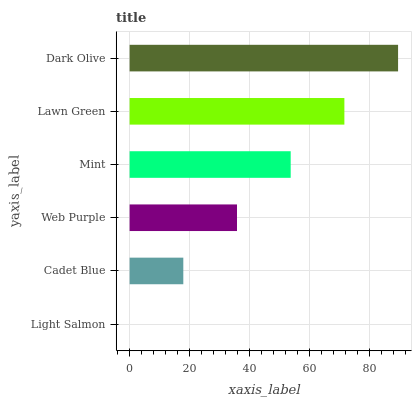Is Light Salmon the minimum?
Answer yes or no. Yes. Is Dark Olive the maximum?
Answer yes or no. Yes. Is Cadet Blue the minimum?
Answer yes or no. No. Is Cadet Blue the maximum?
Answer yes or no. No. Is Cadet Blue greater than Light Salmon?
Answer yes or no. Yes. Is Light Salmon less than Cadet Blue?
Answer yes or no. Yes. Is Light Salmon greater than Cadet Blue?
Answer yes or no. No. Is Cadet Blue less than Light Salmon?
Answer yes or no. No. Is Mint the high median?
Answer yes or no. Yes. Is Web Purple the low median?
Answer yes or no. Yes. Is Web Purple the high median?
Answer yes or no. No. Is Light Salmon the low median?
Answer yes or no. No. 